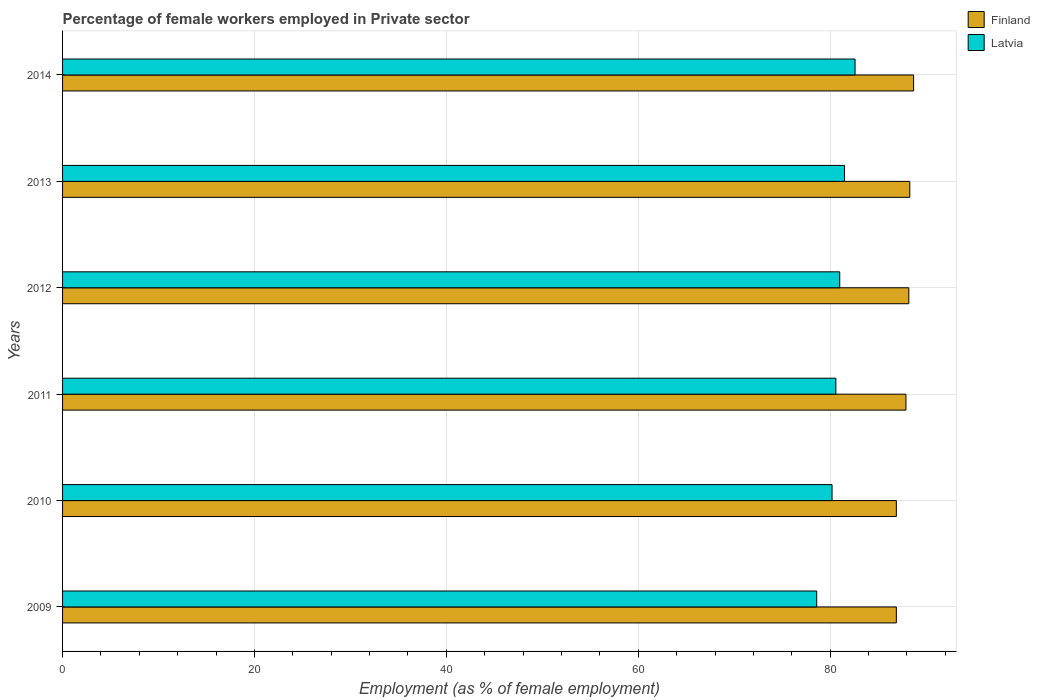Are the number of bars per tick equal to the number of legend labels?
Provide a succinct answer. Yes. Are the number of bars on each tick of the Y-axis equal?
Ensure brevity in your answer.  Yes. How many bars are there on the 6th tick from the top?
Your answer should be compact. 2. What is the percentage of females employed in Private sector in Finland in 2012?
Your answer should be compact. 88.2. Across all years, what is the maximum percentage of females employed in Private sector in Finland?
Make the answer very short. 88.7. Across all years, what is the minimum percentage of females employed in Private sector in Finland?
Ensure brevity in your answer.  86.9. What is the total percentage of females employed in Private sector in Finland in the graph?
Keep it short and to the point. 526.9. What is the difference between the percentage of females employed in Private sector in Finland in 2009 and that in 2013?
Your response must be concise. -1.4. What is the difference between the percentage of females employed in Private sector in Finland in 2009 and the percentage of females employed in Private sector in Latvia in 2013?
Your answer should be compact. 5.4. What is the average percentage of females employed in Private sector in Finland per year?
Offer a very short reply. 87.82. In the year 2013, what is the difference between the percentage of females employed in Private sector in Latvia and percentage of females employed in Private sector in Finland?
Provide a succinct answer. -6.8. What is the ratio of the percentage of females employed in Private sector in Finland in 2010 to that in 2011?
Give a very brief answer. 0.99. Is the percentage of females employed in Private sector in Latvia in 2010 less than that in 2011?
Offer a terse response. Yes. What is the difference between the highest and the second highest percentage of females employed in Private sector in Latvia?
Give a very brief answer. 1.1. What is the difference between the highest and the lowest percentage of females employed in Private sector in Finland?
Offer a very short reply. 1.8. In how many years, is the percentage of females employed in Private sector in Finland greater than the average percentage of females employed in Private sector in Finland taken over all years?
Your answer should be compact. 4. What does the 1st bar from the top in 2013 represents?
Ensure brevity in your answer.  Latvia. How many bars are there?
Ensure brevity in your answer.  12. How many years are there in the graph?
Your answer should be very brief. 6. What is the difference between two consecutive major ticks on the X-axis?
Offer a very short reply. 20. How many legend labels are there?
Offer a very short reply. 2. What is the title of the graph?
Provide a short and direct response. Percentage of female workers employed in Private sector. What is the label or title of the X-axis?
Provide a succinct answer. Employment (as % of female employment). What is the Employment (as % of female employment) in Finland in 2009?
Ensure brevity in your answer.  86.9. What is the Employment (as % of female employment) of Latvia in 2009?
Offer a terse response. 78.6. What is the Employment (as % of female employment) of Finland in 2010?
Give a very brief answer. 86.9. What is the Employment (as % of female employment) of Latvia in 2010?
Offer a terse response. 80.2. What is the Employment (as % of female employment) of Finland in 2011?
Your answer should be very brief. 87.9. What is the Employment (as % of female employment) in Latvia in 2011?
Your answer should be compact. 80.6. What is the Employment (as % of female employment) of Finland in 2012?
Keep it short and to the point. 88.2. What is the Employment (as % of female employment) in Finland in 2013?
Ensure brevity in your answer.  88.3. What is the Employment (as % of female employment) of Latvia in 2013?
Offer a terse response. 81.5. What is the Employment (as % of female employment) of Finland in 2014?
Provide a short and direct response. 88.7. What is the Employment (as % of female employment) in Latvia in 2014?
Make the answer very short. 82.6. Across all years, what is the maximum Employment (as % of female employment) of Finland?
Ensure brevity in your answer.  88.7. Across all years, what is the maximum Employment (as % of female employment) in Latvia?
Your answer should be compact. 82.6. Across all years, what is the minimum Employment (as % of female employment) of Finland?
Offer a very short reply. 86.9. Across all years, what is the minimum Employment (as % of female employment) of Latvia?
Ensure brevity in your answer.  78.6. What is the total Employment (as % of female employment) of Finland in the graph?
Provide a short and direct response. 526.9. What is the total Employment (as % of female employment) of Latvia in the graph?
Give a very brief answer. 484.5. What is the difference between the Employment (as % of female employment) in Finland in 2009 and that in 2011?
Make the answer very short. -1. What is the difference between the Employment (as % of female employment) of Finland in 2009 and that in 2012?
Provide a short and direct response. -1.3. What is the difference between the Employment (as % of female employment) of Finland in 2009 and that in 2013?
Your answer should be very brief. -1.4. What is the difference between the Employment (as % of female employment) in Latvia in 2009 and that in 2014?
Offer a very short reply. -4. What is the difference between the Employment (as % of female employment) of Finland in 2010 and that in 2011?
Offer a terse response. -1. What is the difference between the Employment (as % of female employment) of Latvia in 2010 and that in 2011?
Make the answer very short. -0.4. What is the difference between the Employment (as % of female employment) in Latvia in 2011 and that in 2012?
Give a very brief answer. -0.4. What is the difference between the Employment (as % of female employment) in Latvia in 2011 and that in 2013?
Provide a succinct answer. -0.9. What is the difference between the Employment (as % of female employment) of Finland in 2011 and that in 2014?
Your response must be concise. -0.8. What is the difference between the Employment (as % of female employment) in Finland in 2012 and that in 2013?
Keep it short and to the point. -0.1. What is the difference between the Employment (as % of female employment) in Finland in 2012 and that in 2014?
Make the answer very short. -0.5. What is the difference between the Employment (as % of female employment) of Latvia in 2013 and that in 2014?
Provide a succinct answer. -1.1. What is the difference between the Employment (as % of female employment) in Finland in 2009 and the Employment (as % of female employment) in Latvia in 2010?
Provide a short and direct response. 6.7. What is the difference between the Employment (as % of female employment) of Finland in 2009 and the Employment (as % of female employment) of Latvia in 2012?
Offer a terse response. 5.9. What is the difference between the Employment (as % of female employment) in Finland in 2009 and the Employment (as % of female employment) in Latvia in 2013?
Keep it short and to the point. 5.4. What is the difference between the Employment (as % of female employment) of Finland in 2010 and the Employment (as % of female employment) of Latvia in 2014?
Give a very brief answer. 4.3. What is the difference between the Employment (as % of female employment) in Finland in 2011 and the Employment (as % of female employment) in Latvia in 2013?
Your answer should be very brief. 6.4. What is the difference between the Employment (as % of female employment) in Finland in 2011 and the Employment (as % of female employment) in Latvia in 2014?
Your answer should be compact. 5.3. What is the difference between the Employment (as % of female employment) of Finland in 2013 and the Employment (as % of female employment) of Latvia in 2014?
Your response must be concise. 5.7. What is the average Employment (as % of female employment) in Finland per year?
Your response must be concise. 87.82. What is the average Employment (as % of female employment) of Latvia per year?
Your response must be concise. 80.75. In the year 2012, what is the difference between the Employment (as % of female employment) in Finland and Employment (as % of female employment) in Latvia?
Keep it short and to the point. 7.2. In the year 2013, what is the difference between the Employment (as % of female employment) of Finland and Employment (as % of female employment) of Latvia?
Your response must be concise. 6.8. What is the ratio of the Employment (as % of female employment) of Finland in 2009 to that in 2011?
Give a very brief answer. 0.99. What is the ratio of the Employment (as % of female employment) of Latvia in 2009 to that in 2011?
Your answer should be compact. 0.98. What is the ratio of the Employment (as % of female employment) of Finland in 2009 to that in 2012?
Provide a succinct answer. 0.99. What is the ratio of the Employment (as % of female employment) of Latvia in 2009 to that in 2012?
Your answer should be very brief. 0.97. What is the ratio of the Employment (as % of female employment) of Finland in 2009 to that in 2013?
Provide a short and direct response. 0.98. What is the ratio of the Employment (as % of female employment) of Latvia in 2009 to that in 2013?
Provide a succinct answer. 0.96. What is the ratio of the Employment (as % of female employment) of Finland in 2009 to that in 2014?
Your answer should be compact. 0.98. What is the ratio of the Employment (as % of female employment) in Latvia in 2009 to that in 2014?
Provide a short and direct response. 0.95. What is the ratio of the Employment (as % of female employment) in Latvia in 2010 to that in 2011?
Your answer should be compact. 0.99. What is the ratio of the Employment (as % of female employment) of Finland in 2010 to that in 2012?
Provide a short and direct response. 0.99. What is the ratio of the Employment (as % of female employment) of Finland in 2010 to that in 2013?
Offer a very short reply. 0.98. What is the ratio of the Employment (as % of female employment) of Finland in 2010 to that in 2014?
Make the answer very short. 0.98. What is the ratio of the Employment (as % of female employment) of Latvia in 2010 to that in 2014?
Provide a succinct answer. 0.97. What is the ratio of the Employment (as % of female employment) of Latvia in 2011 to that in 2013?
Ensure brevity in your answer.  0.99. What is the ratio of the Employment (as % of female employment) in Latvia in 2011 to that in 2014?
Your answer should be very brief. 0.98. What is the ratio of the Employment (as % of female employment) in Latvia in 2012 to that in 2013?
Offer a terse response. 0.99. What is the ratio of the Employment (as % of female employment) in Latvia in 2012 to that in 2014?
Your answer should be very brief. 0.98. What is the ratio of the Employment (as % of female employment) in Finland in 2013 to that in 2014?
Ensure brevity in your answer.  1. What is the ratio of the Employment (as % of female employment) of Latvia in 2013 to that in 2014?
Provide a succinct answer. 0.99. What is the difference between the highest and the lowest Employment (as % of female employment) of Finland?
Your answer should be very brief. 1.8. 